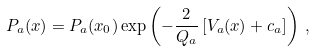Convert formula to latex. <formula><loc_0><loc_0><loc_500><loc_500>P _ { a } ( x ) = P _ { a } ( x _ { 0 } ) \exp \left ( - \frac { 2 } { Q _ { a } } \left [ V _ { a } ( x ) + c _ { a } \right ] \right ) \, ,</formula> 